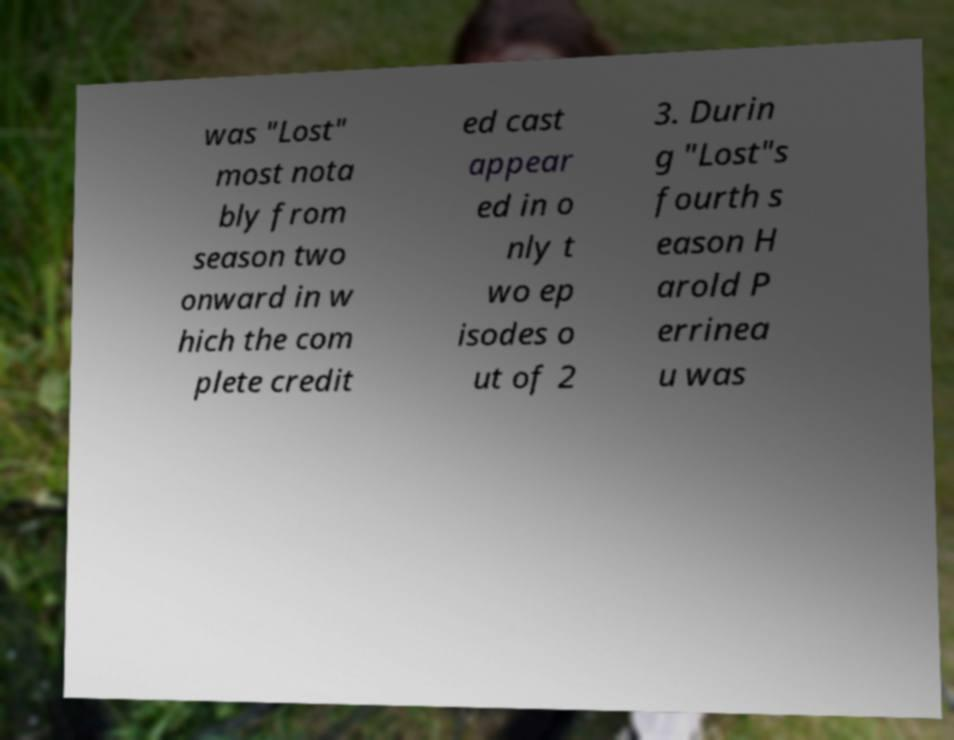Please identify and transcribe the text found in this image. was "Lost" most nota bly from season two onward in w hich the com plete credit ed cast appear ed in o nly t wo ep isodes o ut of 2 3. Durin g "Lost"s fourth s eason H arold P errinea u was 